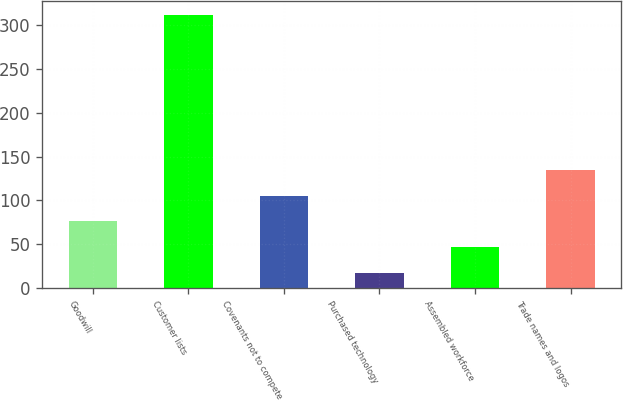Convert chart to OTSL. <chart><loc_0><loc_0><loc_500><loc_500><bar_chart><fcel>Goodwill<fcel>Customer lists<fcel>Covenants not to compete<fcel>Purchased technology<fcel>Assembled workforce<fcel>Trade names and logos<nl><fcel>76<fcel>312<fcel>105.5<fcel>17<fcel>46.5<fcel>135<nl></chart> 